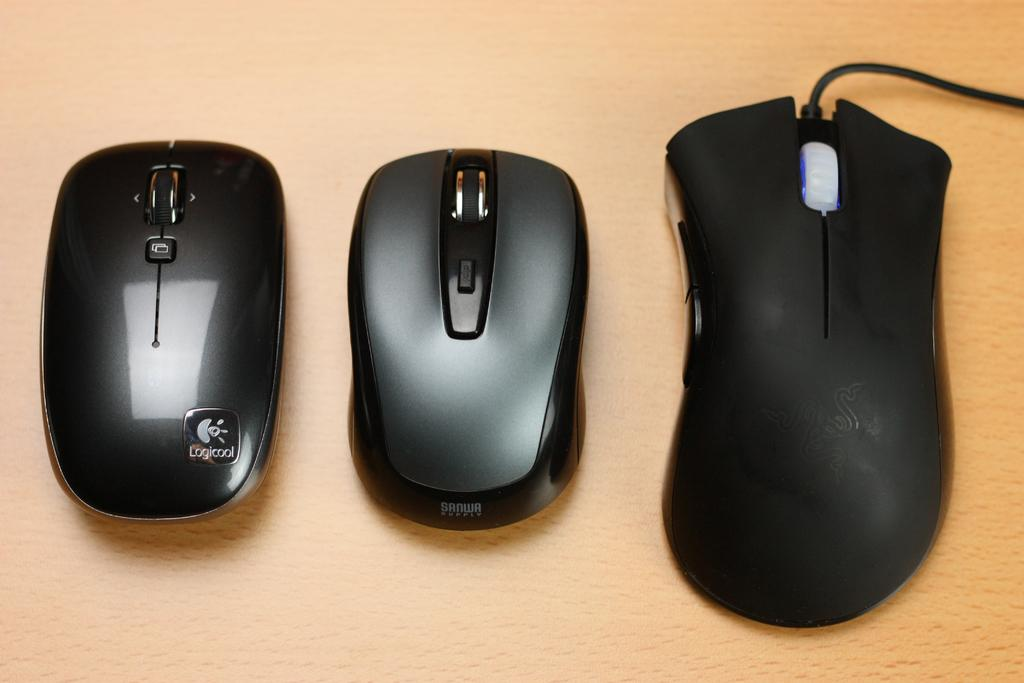What type of furniture is present in the image? There is a table in the image. What electronic devices can be seen on the table? There are two wireless mouses and a wired mouse on the table. How much money is on the table in the image? There is no money present on the table in the image. Is there a source of water visible in the image? There is no water or any reference to a bath in the image. 